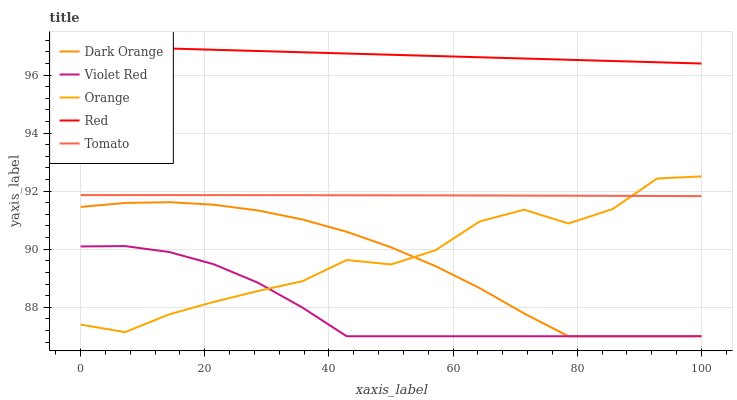Does Violet Red have the minimum area under the curve?
Answer yes or no. Yes. Does Red have the maximum area under the curve?
Answer yes or no. Yes. Does Dark Orange have the minimum area under the curve?
Answer yes or no. No. Does Dark Orange have the maximum area under the curve?
Answer yes or no. No. Is Red the smoothest?
Answer yes or no. Yes. Is Orange the roughest?
Answer yes or no. Yes. Is Dark Orange the smoothest?
Answer yes or no. No. Is Dark Orange the roughest?
Answer yes or no. No. Does Tomato have the lowest value?
Answer yes or no. No. Does Red have the highest value?
Answer yes or no. Yes. Does Dark Orange have the highest value?
Answer yes or no. No. Is Violet Red less than Tomato?
Answer yes or no. Yes. Is Red greater than Orange?
Answer yes or no. Yes. Does Orange intersect Dark Orange?
Answer yes or no. Yes. Is Orange less than Dark Orange?
Answer yes or no. No. Is Orange greater than Dark Orange?
Answer yes or no. No. Does Violet Red intersect Tomato?
Answer yes or no. No. 